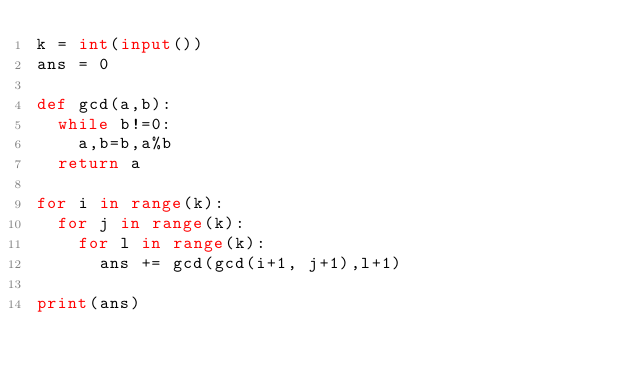<code> <loc_0><loc_0><loc_500><loc_500><_Python_>k = int(input())
ans = 0
 
def gcd(a,b):
  while b!=0:
    a,b=b,a%b
  return a
 
for i in range(k):
  for j in range(k):
    for l in range(k):
      ans += gcd(gcd(i+1, j+1),l+1)
      
print(ans)</code> 